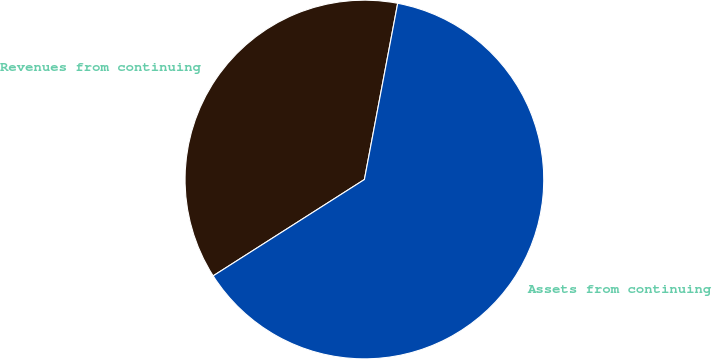Convert chart to OTSL. <chart><loc_0><loc_0><loc_500><loc_500><pie_chart><fcel>Revenues from continuing<fcel>Assets from continuing<nl><fcel>37.0%<fcel>63.0%<nl></chart> 